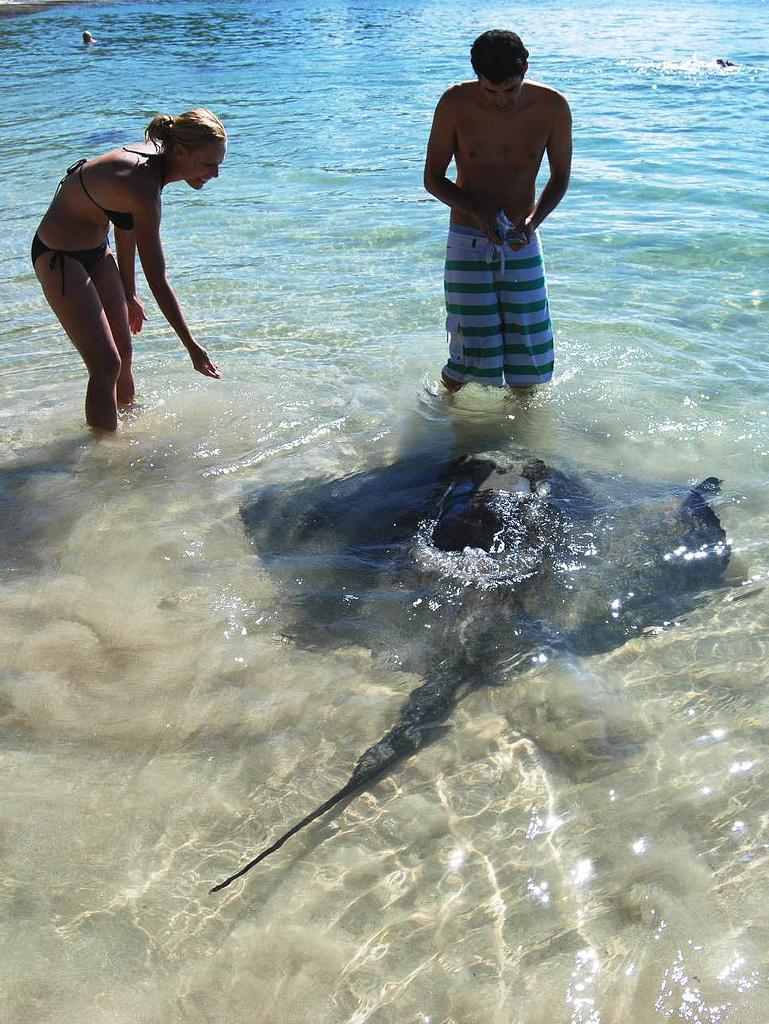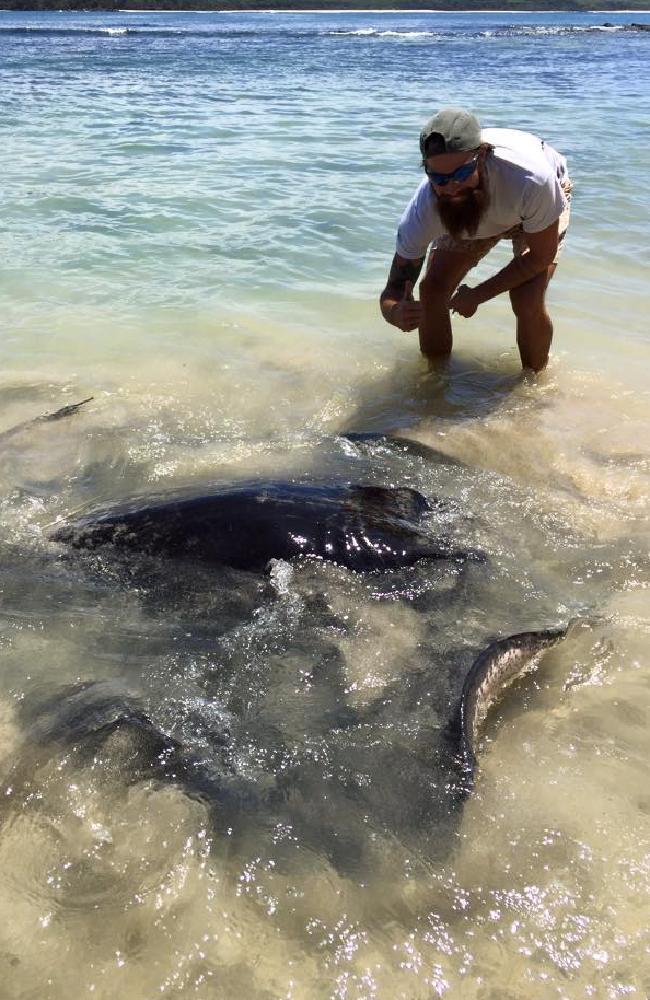The first image is the image on the left, the second image is the image on the right. Considering the images on both sides, is "There is a person reaching down and touching a stingray." valid? Answer yes or no. No. The first image is the image on the left, the second image is the image on the right. For the images shown, is this caption "In the right image a human is petting a stingray" true? Answer yes or no. No. 